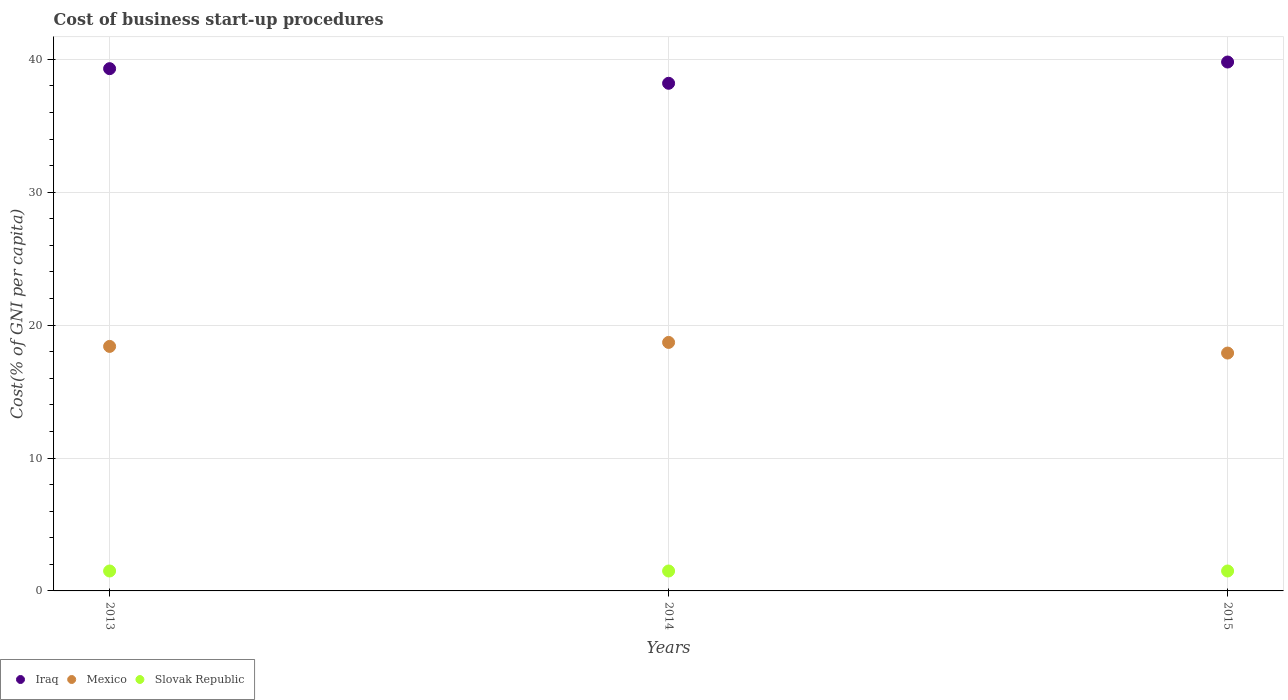How many different coloured dotlines are there?
Offer a terse response. 3. Is the number of dotlines equal to the number of legend labels?
Provide a succinct answer. Yes. What is the cost of business start-up procedures in Slovak Republic in 2013?
Ensure brevity in your answer.  1.5. Across all years, what is the minimum cost of business start-up procedures in Slovak Republic?
Make the answer very short. 1.5. What is the total cost of business start-up procedures in Iraq in the graph?
Ensure brevity in your answer.  117.3. What is the difference between the cost of business start-up procedures in Iraq in 2015 and the cost of business start-up procedures in Mexico in 2014?
Ensure brevity in your answer.  21.1. In the year 2013, what is the difference between the cost of business start-up procedures in Mexico and cost of business start-up procedures in Iraq?
Keep it short and to the point. -20.9. What is the ratio of the cost of business start-up procedures in Mexico in 2013 to that in 2015?
Offer a very short reply. 1.03. What is the difference between the highest and the second highest cost of business start-up procedures in Mexico?
Your answer should be very brief. 0.3. What is the difference between the highest and the lowest cost of business start-up procedures in Mexico?
Your answer should be very brief. 0.8. In how many years, is the cost of business start-up procedures in Mexico greater than the average cost of business start-up procedures in Mexico taken over all years?
Keep it short and to the point. 2. Is the sum of the cost of business start-up procedures in Iraq in 2013 and 2015 greater than the maximum cost of business start-up procedures in Slovak Republic across all years?
Your response must be concise. Yes. Does the cost of business start-up procedures in Mexico monotonically increase over the years?
Your response must be concise. No. Is the cost of business start-up procedures in Iraq strictly less than the cost of business start-up procedures in Mexico over the years?
Give a very brief answer. No. How many dotlines are there?
Your response must be concise. 3. How many years are there in the graph?
Offer a very short reply. 3. What is the difference between two consecutive major ticks on the Y-axis?
Keep it short and to the point. 10. Are the values on the major ticks of Y-axis written in scientific E-notation?
Provide a succinct answer. No. How many legend labels are there?
Your response must be concise. 3. How are the legend labels stacked?
Offer a very short reply. Horizontal. What is the title of the graph?
Your answer should be very brief. Cost of business start-up procedures. What is the label or title of the Y-axis?
Your answer should be very brief. Cost(% of GNI per capita). What is the Cost(% of GNI per capita) of Iraq in 2013?
Your response must be concise. 39.3. What is the Cost(% of GNI per capita) of Mexico in 2013?
Your answer should be very brief. 18.4. What is the Cost(% of GNI per capita) of Iraq in 2014?
Make the answer very short. 38.2. What is the Cost(% of GNI per capita) of Mexico in 2014?
Provide a succinct answer. 18.7. What is the Cost(% of GNI per capita) of Iraq in 2015?
Your response must be concise. 39.8. What is the Cost(% of GNI per capita) in Mexico in 2015?
Your answer should be very brief. 17.9. What is the Cost(% of GNI per capita) of Slovak Republic in 2015?
Offer a terse response. 1.5. Across all years, what is the maximum Cost(% of GNI per capita) of Iraq?
Make the answer very short. 39.8. Across all years, what is the maximum Cost(% of GNI per capita) of Slovak Republic?
Provide a short and direct response. 1.5. Across all years, what is the minimum Cost(% of GNI per capita) of Iraq?
Your response must be concise. 38.2. What is the total Cost(% of GNI per capita) in Iraq in the graph?
Offer a very short reply. 117.3. What is the total Cost(% of GNI per capita) of Mexico in the graph?
Your answer should be very brief. 55. What is the difference between the Cost(% of GNI per capita) of Mexico in 2013 and that in 2014?
Make the answer very short. -0.3. What is the difference between the Cost(% of GNI per capita) in Slovak Republic in 2013 and that in 2014?
Provide a succinct answer. 0. What is the difference between the Cost(% of GNI per capita) in Slovak Republic in 2013 and that in 2015?
Give a very brief answer. 0. What is the difference between the Cost(% of GNI per capita) in Mexico in 2014 and that in 2015?
Your answer should be very brief. 0.8. What is the difference between the Cost(% of GNI per capita) of Iraq in 2013 and the Cost(% of GNI per capita) of Mexico in 2014?
Offer a terse response. 20.6. What is the difference between the Cost(% of GNI per capita) of Iraq in 2013 and the Cost(% of GNI per capita) of Slovak Republic in 2014?
Your response must be concise. 37.8. What is the difference between the Cost(% of GNI per capita) in Iraq in 2013 and the Cost(% of GNI per capita) in Mexico in 2015?
Your answer should be compact. 21.4. What is the difference between the Cost(% of GNI per capita) of Iraq in 2013 and the Cost(% of GNI per capita) of Slovak Republic in 2015?
Offer a very short reply. 37.8. What is the difference between the Cost(% of GNI per capita) in Iraq in 2014 and the Cost(% of GNI per capita) in Mexico in 2015?
Your response must be concise. 20.3. What is the difference between the Cost(% of GNI per capita) of Iraq in 2014 and the Cost(% of GNI per capita) of Slovak Republic in 2015?
Your answer should be compact. 36.7. What is the difference between the Cost(% of GNI per capita) of Mexico in 2014 and the Cost(% of GNI per capita) of Slovak Republic in 2015?
Provide a succinct answer. 17.2. What is the average Cost(% of GNI per capita) of Iraq per year?
Offer a terse response. 39.1. What is the average Cost(% of GNI per capita) of Mexico per year?
Give a very brief answer. 18.33. In the year 2013, what is the difference between the Cost(% of GNI per capita) of Iraq and Cost(% of GNI per capita) of Mexico?
Your answer should be very brief. 20.9. In the year 2013, what is the difference between the Cost(% of GNI per capita) in Iraq and Cost(% of GNI per capita) in Slovak Republic?
Your response must be concise. 37.8. In the year 2013, what is the difference between the Cost(% of GNI per capita) in Mexico and Cost(% of GNI per capita) in Slovak Republic?
Your answer should be compact. 16.9. In the year 2014, what is the difference between the Cost(% of GNI per capita) of Iraq and Cost(% of GNI per capita) of Mexico?
Ensure brevity in your answer.  19.5. In the year 2014, what is the difference between the Cost(% of GNI per capita) of Iraq and Cost(% of GNI per capita) of Slovak Republic?
Your response must be concise. 36.7. In the year 2015, what is the difference between the Cost(% of GNI per capita) in Iraq and Cost(% of GNI per capita) in Mexico?
Your response must be concise. 21.9. In the year 2015, what is the difference between the Cost(% of GNI per capita) in Iraq and Cost(% of GNI per capita) in Slovak Republic?
Provide a succinct answer. 38.3. In the year 2015, what is the difference between the Cost(% of GNI per capita) of Mexico and Cost(% of GNI per capita) of Slovak Republic?
Provide a short and direct response. 16.4. What is the ratio of the Cost(% of GNI per capita) of Iraq in 2013 to that in 2014?
Your answer should be very brief. 1.03. What is the ratio of the Cost(% of GNI per capita) of Slovak Republic in 2013 to that in 2014?
Ensure brevity in your answer.  1. What is the ratio of the Cost(% of GNI per capita) in Iraq in 2013 to that in 2015?
Give a very brief answer. 0.99. What is the ratio of the Cost(% of GNI per capita) in Mexico in 2013 to that in 2015?
Keep it short and to the point. 1.03. What is the ratio of the Cost(% of GNI per capita) of Iraq in 2014 to that in 2015?
Give a very brief answer. 0.96. What is the ratio of the Cost(% of GNI per capita) of Mexico in 2014 to that in 2015?
Your answer should be very brief. 1.04. What is the difference between the highest and the second highest Cost(% of GNI per capita) in Slovak Republic?
Provide a short and direct response. 0. What is the difference between the highest and the lowest Cost(% of GNI per capita) in Iraq?
Your response must be concise. 1.6. What is the difference between the highest and the lowest Cost(% of GNI per capita) in Mexico?
Keep it short and to the point. 0.8. 